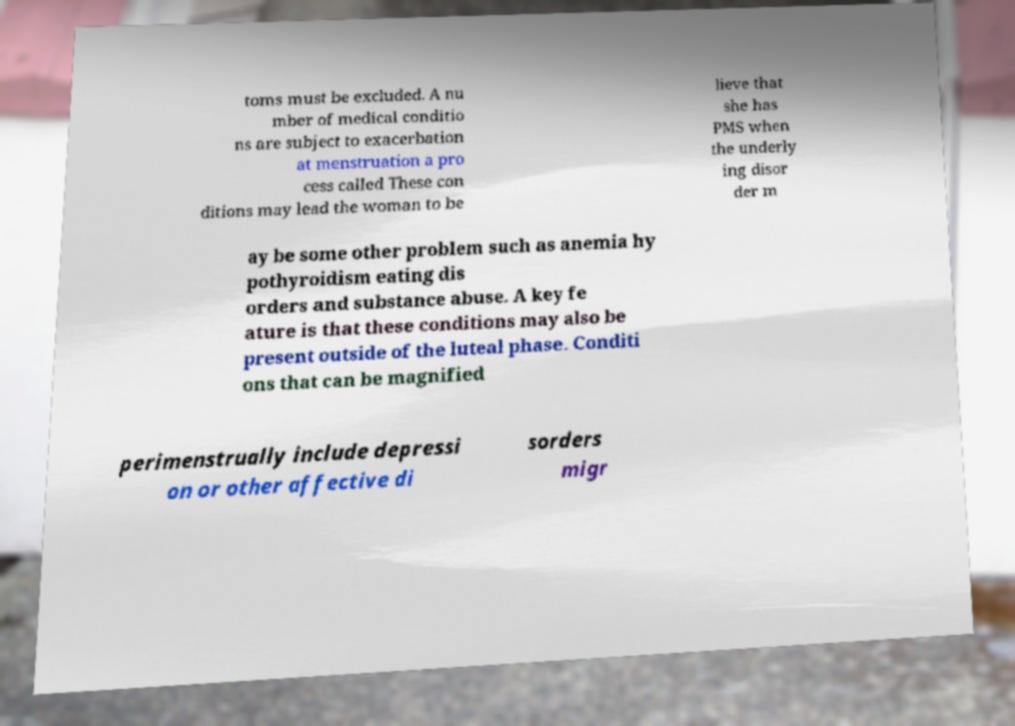Can you read and provide the text displayed in the image?This photo seems to have some interesting text. Can you extract and type it out for me? toms must be excluded. A nu mber of medical conditio ns are subject to exacerbation at menstruation a pro cess called These con ditions may lead the woman to be lieve that she has PMS when the underly ing disor der m ay be some other problem such as anemia hy pothyroidism eating dis orders and substance abuse. A key fe ature is that these conditions may also be present outside of the luteal phase. Conditi ons that can be magnified perimenstrually include depressi on or other affective di sorders migr 